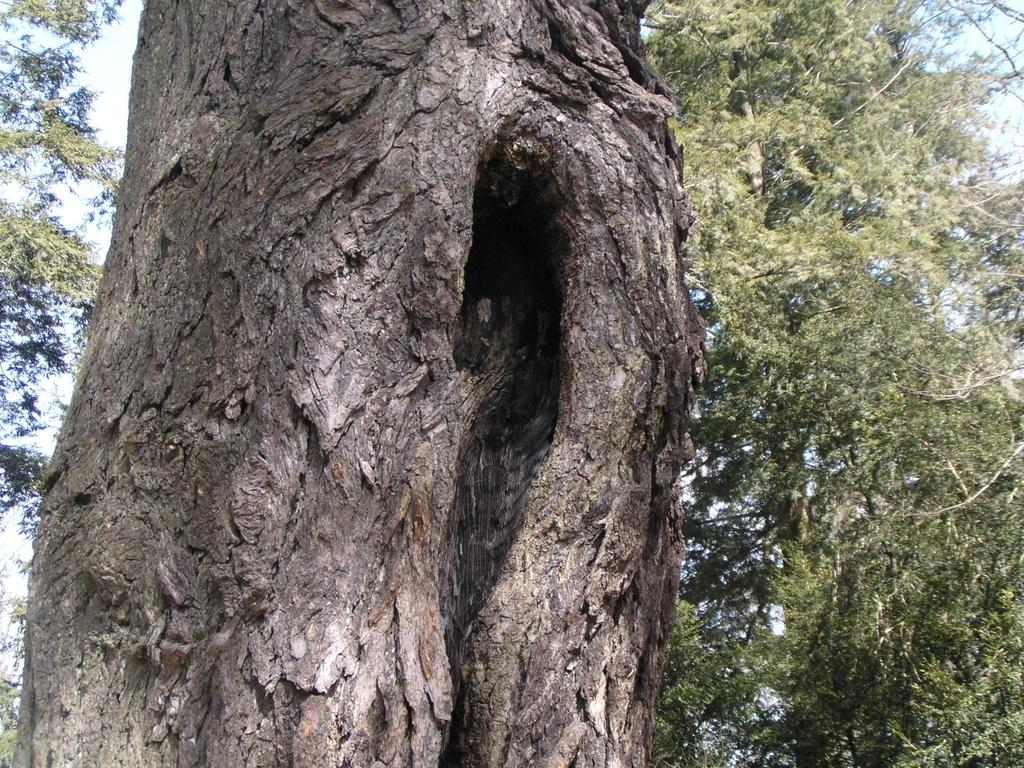What is the primary feature of the image? There are many trees in the image. What can be seen in the background of the image? The sky is visible in the background of the image. What type of cough can be heard in the image? A: There is no sound, including coughing, present in the image. What verse is being recited in the image? There is no recitation or verse present in the image. 